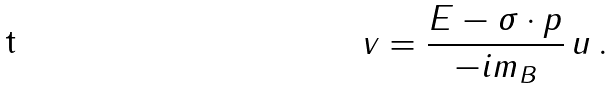Convert formula to latex. <formula><loc_0><loc_0><loc_500><loc_500>v = \frac { E - \sigma \cdot p } { - i m _ { B } } \, u \, .</formula> 